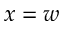<formula> <loc_0><loc_0><loc_500><loc_500>x = w</formula> 